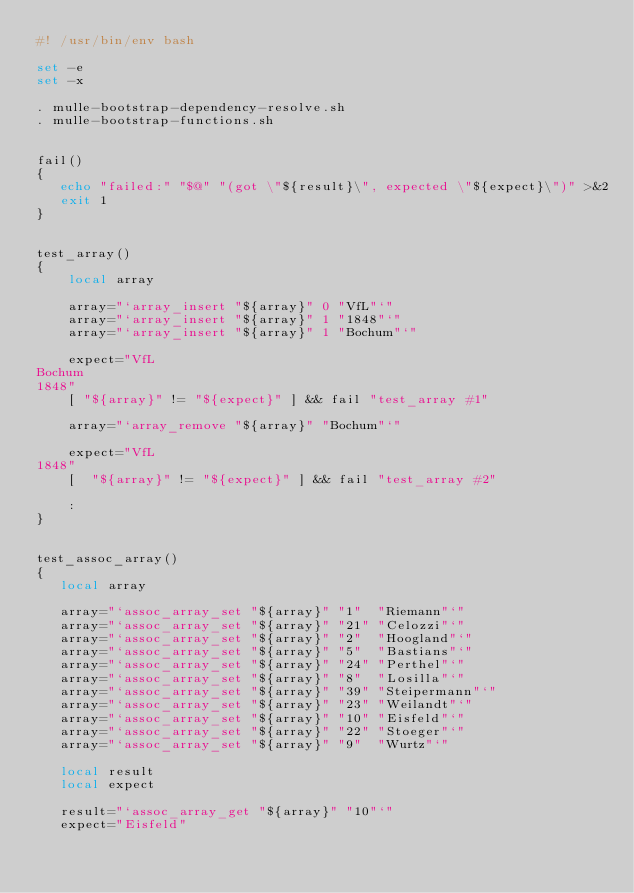<code> <loc_0><loc_0><loc_500><loc_500><_Bash_>#! /usr/bin/env bash

set -e
set -x

. mulle-bootstrap-dependency-resolve.sh
. mulle-bootstrap-functions.sh


fail()
{
   echo "failed:" "$@" "(got \"${result}\", expected \"${expect}\")" >&2
   exit 1
}


test_array()
{
    local array

    array="`array_insert "${array}" 0 "VfL"`"
    array="`array_insert "${array}" 1 "1848"`"
    array="`array_insert "${array}" 1 "Bochum"`"

    expect="VfL
Bochum
1848"
    [ "${array}" != "${expect}" ] && fail "test_array #1"

    array="`array_remove "${array}" "Bochum"`"

    expect="VfL
1848"
    [  "${array}" != "${expect}" ] && fail "test_array #2"

    :
}


test_assoc_array()
{
   local array

   array="`assoc_array_set "${array}" "1"  "Riemann"`"
   array="`assoc_array_set "${array}" "21" "Celozzi"`"
   array="`assoc_array_set "${array}" "2"  "Hoogland"`"
   array="`assoc_array_set "${array}" "5"  "Bastians"`"
   array="`assoc_array_set "${array}" "24" "Perthel"`"
   array="`assoc_array_set "${array}" "8"  "Losilla"`"
   array="`assoc_array_set "${array}" "39" "Steipermann"`"
   array="`assoc_array_set "${array}" "23" "Weilandt"`"
   array="`assoc_array_set "${array}" "10" "Eisfeld"`"
   array="`assoc_array_set "${array}" "22" "Stoeger"`"
   array="`assoc_array_set "${array}" "9"  "Wurtz"`"

   local result
   local expect

   result="`assoc_array_get "${array}" "10"`"
   expect="Eisfeld"</code> 